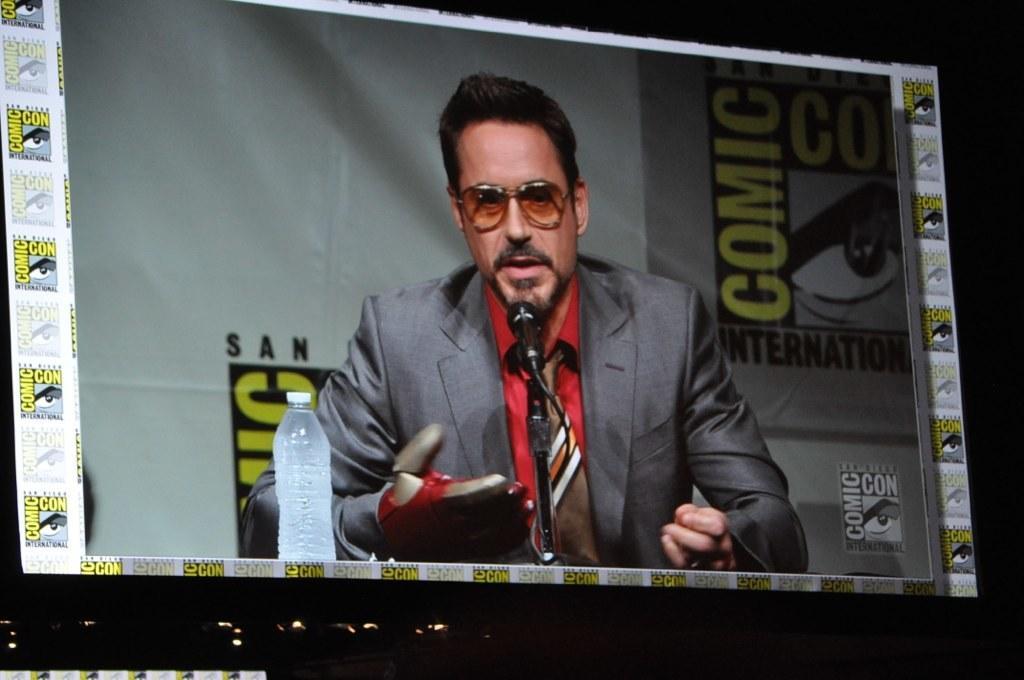Can you describe this image briefly? In this image I can see a man is there, he is speaking in the microphone. He wore tie, shirt, coat. On the left side there is a water bottle. 